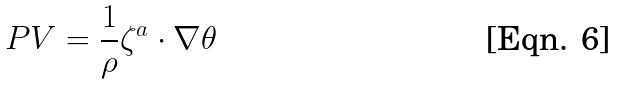<formula> <loc_0><loc_0><loc_500><loc_500>P V = \frac { 1 } { \rho } \zeta ^ { a } \cdot \nabla \theta</formula> 